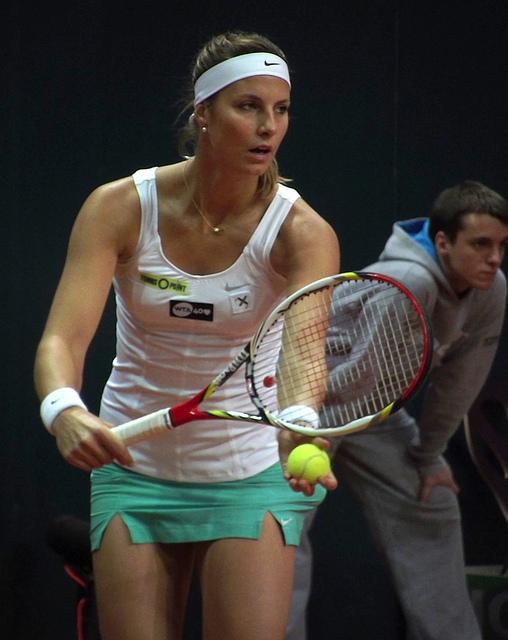What brand is she sponsored by?
Concise answer only. Nike. What is the woman wearing that is pink and green?
Short answer required. Skirt. What letter is on the tennis racket?
Write a very short answer. W. What color headband is she wearing?
Give a very brief answer. White. What color is the woman's arm band?
Give a very brief answer. White. Does she look tired?
Give a very brief answer. Yes. What color is her sports bra?
Answer briefly. White. What game is the lady playing?
Quick response, please. Tennis. What city is listed on her shirt?
Write a very short answer. None. Is this the first serve?
Write a very short answer. Yes. What brand logo is seen on the headband?
Concise answer only. Nike. 